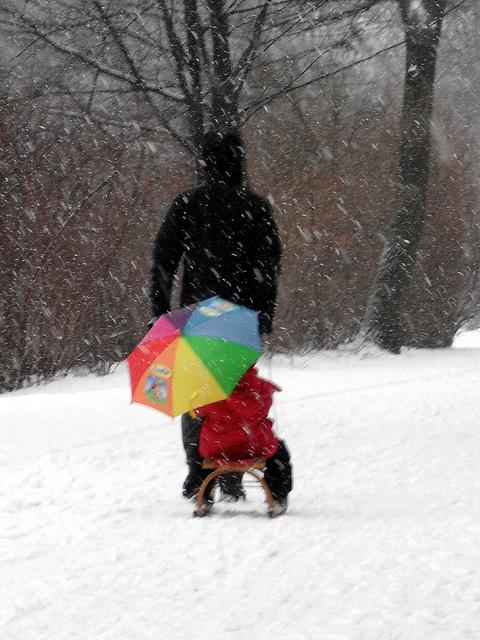In which location might this umbrella be appropriate? rain 